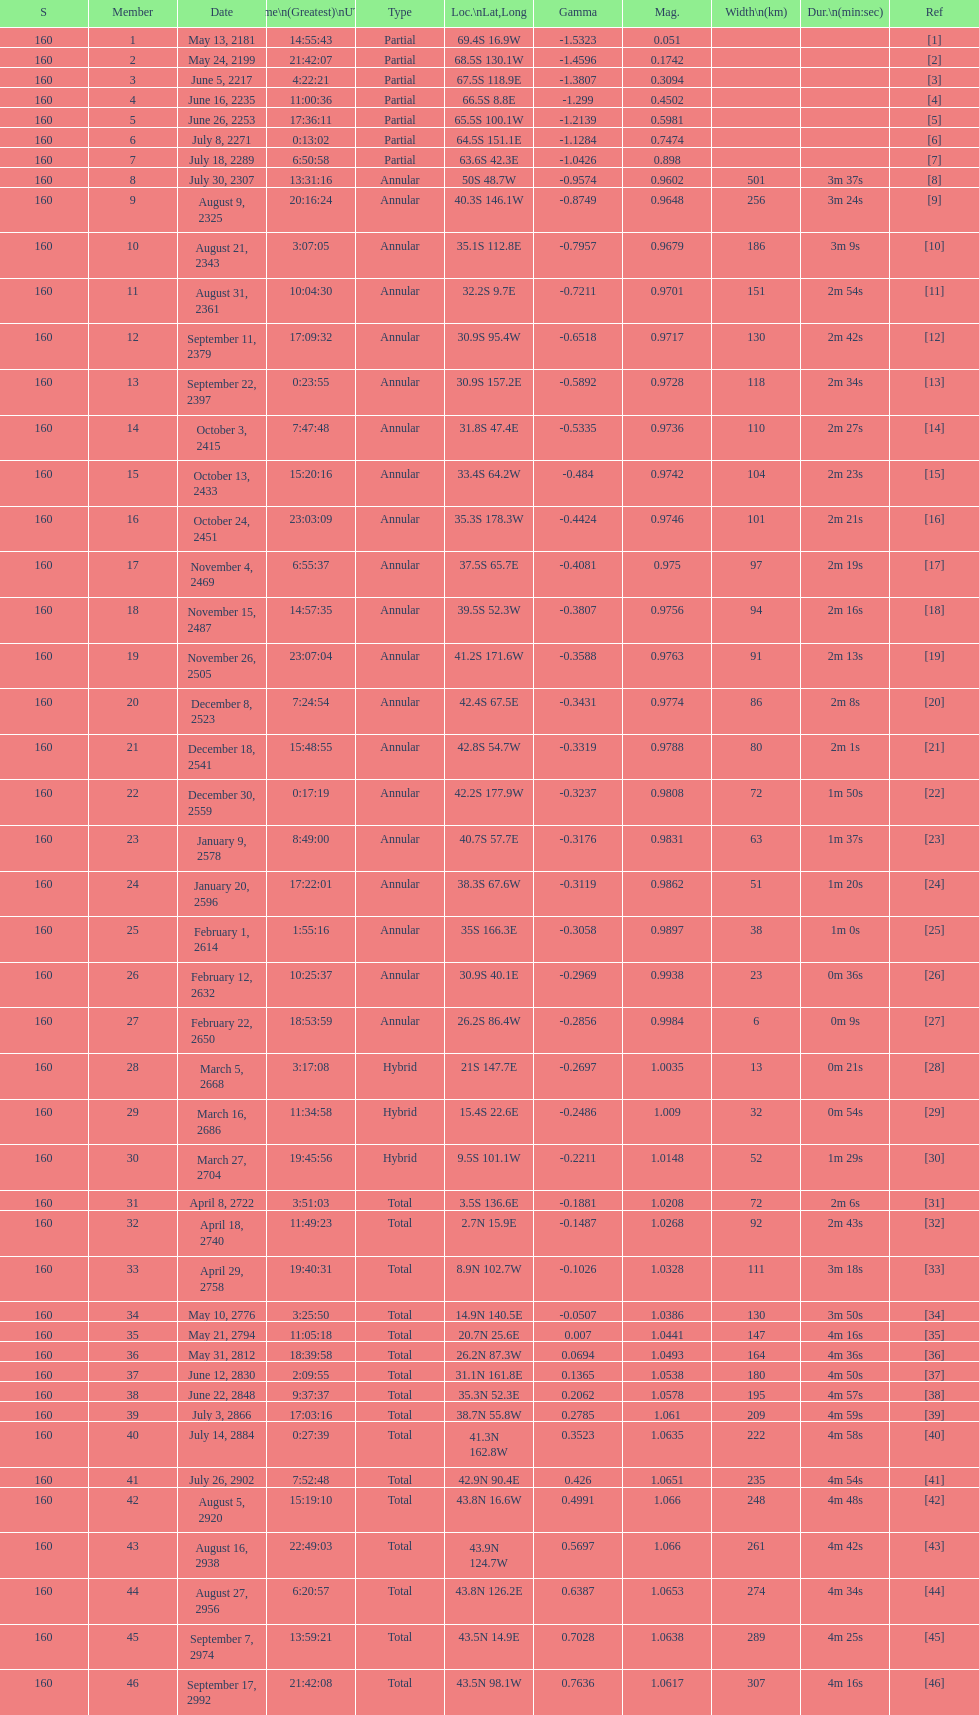When will the next solar saros be after the may 24, 2199 solar saros occurs? June 5, 2217. 